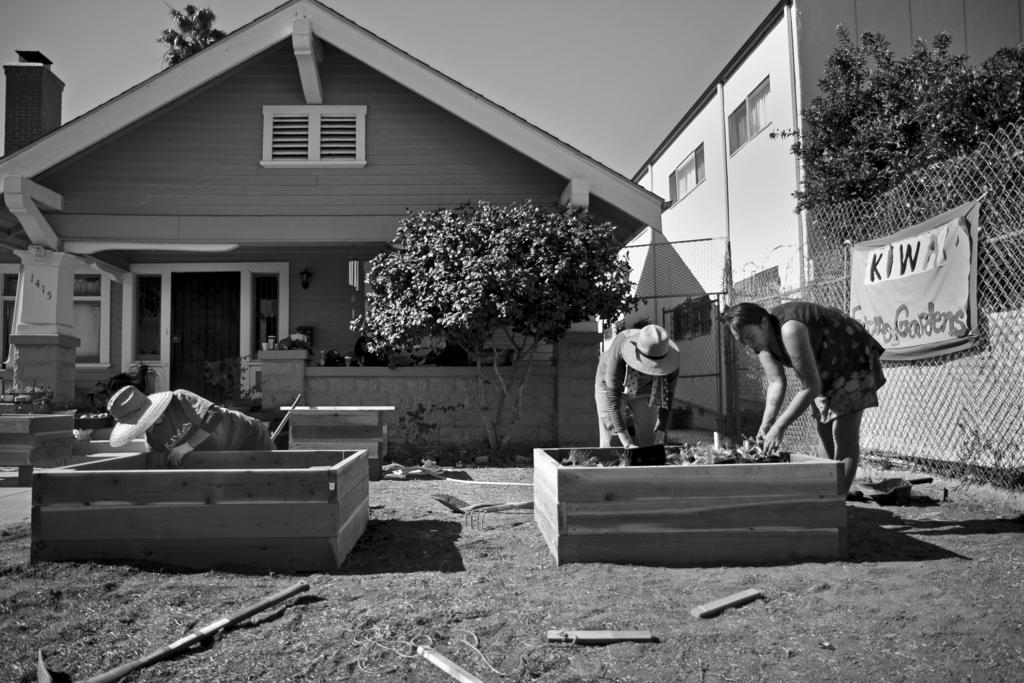Who or what is present in the image? There are people in the image. What can be seen in the distance behind the people? There are houses and trees in the background of the image. What is on the fence in the background? There is a banner on a fence in the background of the image. How is the image presented in terms of color? The photography is in black and white. What type of chain can be seen hanging from the trees in the image? There is no chain present in the image; it features people, houses, trees, and a banner on a fence in a black and white photography. 